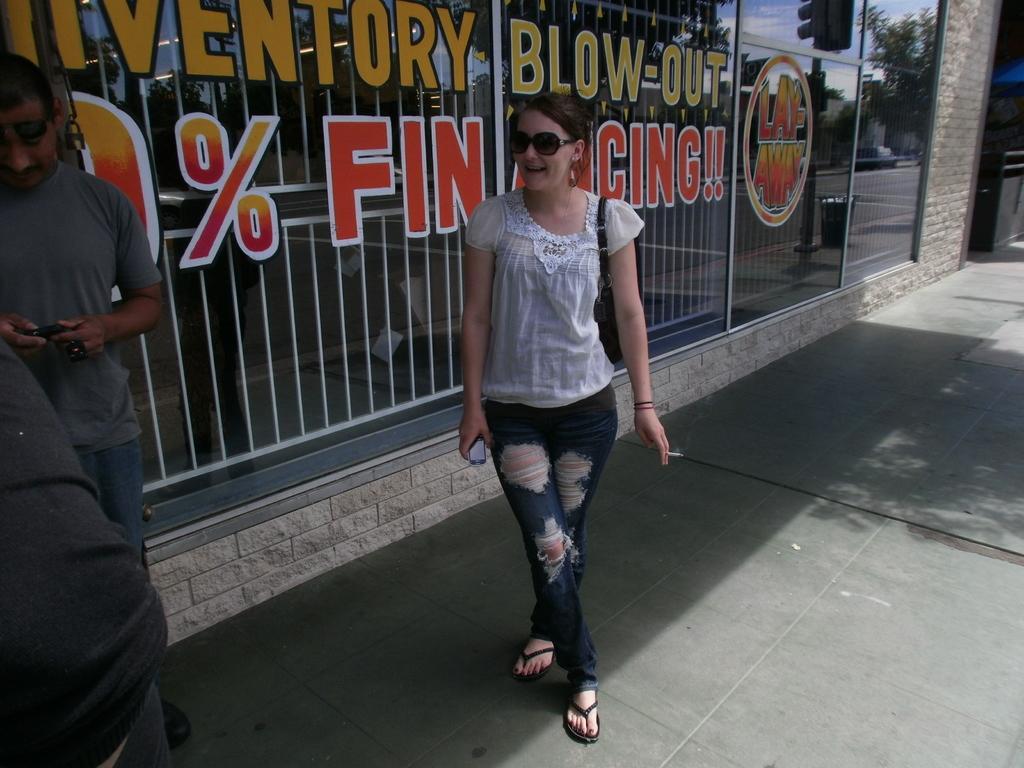Can you describe this image briefly? In the center of the image there is a lady standing. She is holding a cigar in her hand. she is wearing a torn jeans. In the background of the image there is a mirror there is some text written on it. To the left side of the image there is a person. At the bottom of the image there is road. 